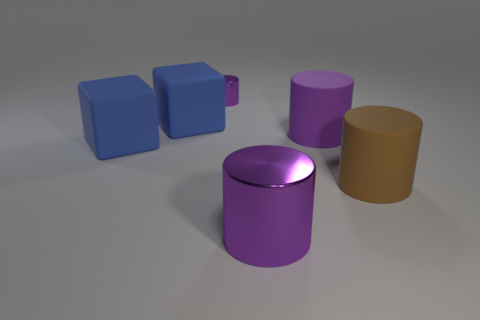There is another large cylinder that is the same color as the big shiny cylinder; what is it made of?
Offer a very short reply. Rubber. How many other objects are there of the same color as the large shiny cylinder?
Keep it short and to the point. 2. Do the brown thing and the metal cylinder behind the brown cylinder have the same size?
Ensure brevity in your answer.  No. How big is the purple shiny cylinder behind the big blue matte object that is in front of the purple rubber cylinder?
Your answer should be very brief. Small. There is another large rubber object that is the same shape as the large purple matte object; what is its color?
Provide a succinct answer. Brown. Do the brown rubber cylinder and the purple rubber cylinder have the same size?
Your response must be concise. Yes. Are there the same number of purple matte objects in front of the big purple rubber cylinder and large cubes?
Offer a terse response. No. There is a rubber block behind the big purple matte object; is there a big metal cylinder that is left of it?
Provide a succinct answer. No. What size is the purple metallic cylinder that is in front of the blue object in front of the matte object behind the purple matte cylinder?
Your answer should be compact. Large. The big purple cylinder behind the purple shiny cylinder to the right of the small metal cylinder is made of what material?
Ensure brevity in your answer.  Rubber. 